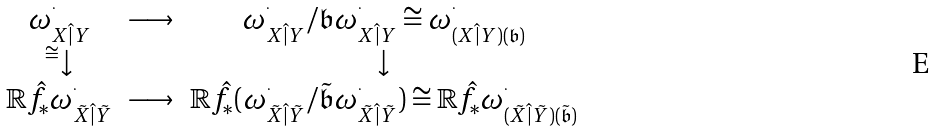<formula> <loc_0><loc_0><loc_500><loc_500>\begin{matrix} \omega ^ { ^ { . } } _ { X \hat { | } Y } & \longrightarrow & \omega ^ { ^ { . } } _ { X \hat { | } Y } / \mathfrak b \omega ^ { ^ { . } } _ { X \hat { | } Y } \cong \omega ^ { ^ { . } } _ { ( X \hat { | } Y ) ( \mathfrak b ) } \\ ^ { \cong } { \downarrow } & & \downarrow \\ \mathbb { R } \hat { f } _ { * } \omega ^ { ^ { . } } _ { \tilde { X } \hat { | } \tilde { Y } } & \longrightarrow & \mathbb { R } \hat { f } _ { * } ( \omega ^ { ^ { . } } _ { \tilde { X } \hat { | } \tilde { Y } } / \tilde { \mathfrak b } \omega ^ { ^ { . } } _ { \tilde { X } \hat { | } \tilde { Y } } ) \cong \mathbb { R } \hat { f } _ { * } \omega ^ { ^ { . } } _ { ( \tilde { X } \hat { | } \tilde { Y } ) ( \tilde { \mathfrak b } ) } \end{matrix}</formula> 